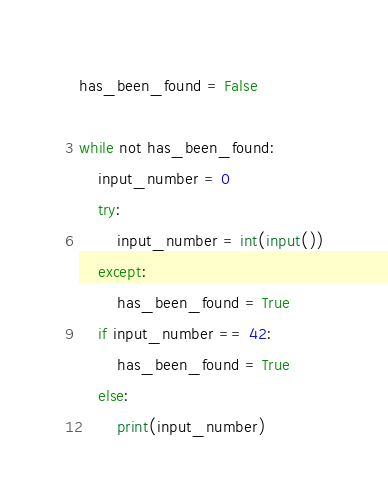<code> <loc_0><loc_0><loc_500><loc_500><_Python_>has_been_found = False

while not has_been_found:
    input_number = 0
    try:
        input_number = int(input())
    except:
        has_been_found = True
    if input_number == 42:
        has_been_found = True
    else:
        print(input_number)
</code> 